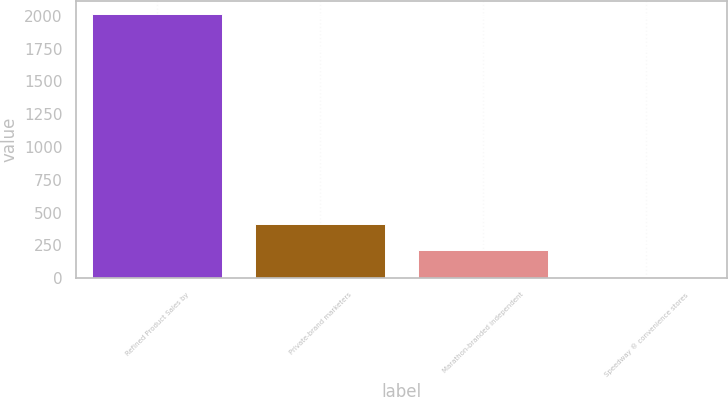<chart> <loc_0><loc_0><loc_500><loc_500><bar_chart><fcel>Refined Product Sales by<fcel>Private-brand marketers<fcel>Marathon-branded independent<fcel>Speedway ® convenience stores<nl><fcel>2014<fcel>412.4<fcel>212.2<fcel>12<nl></chart> 